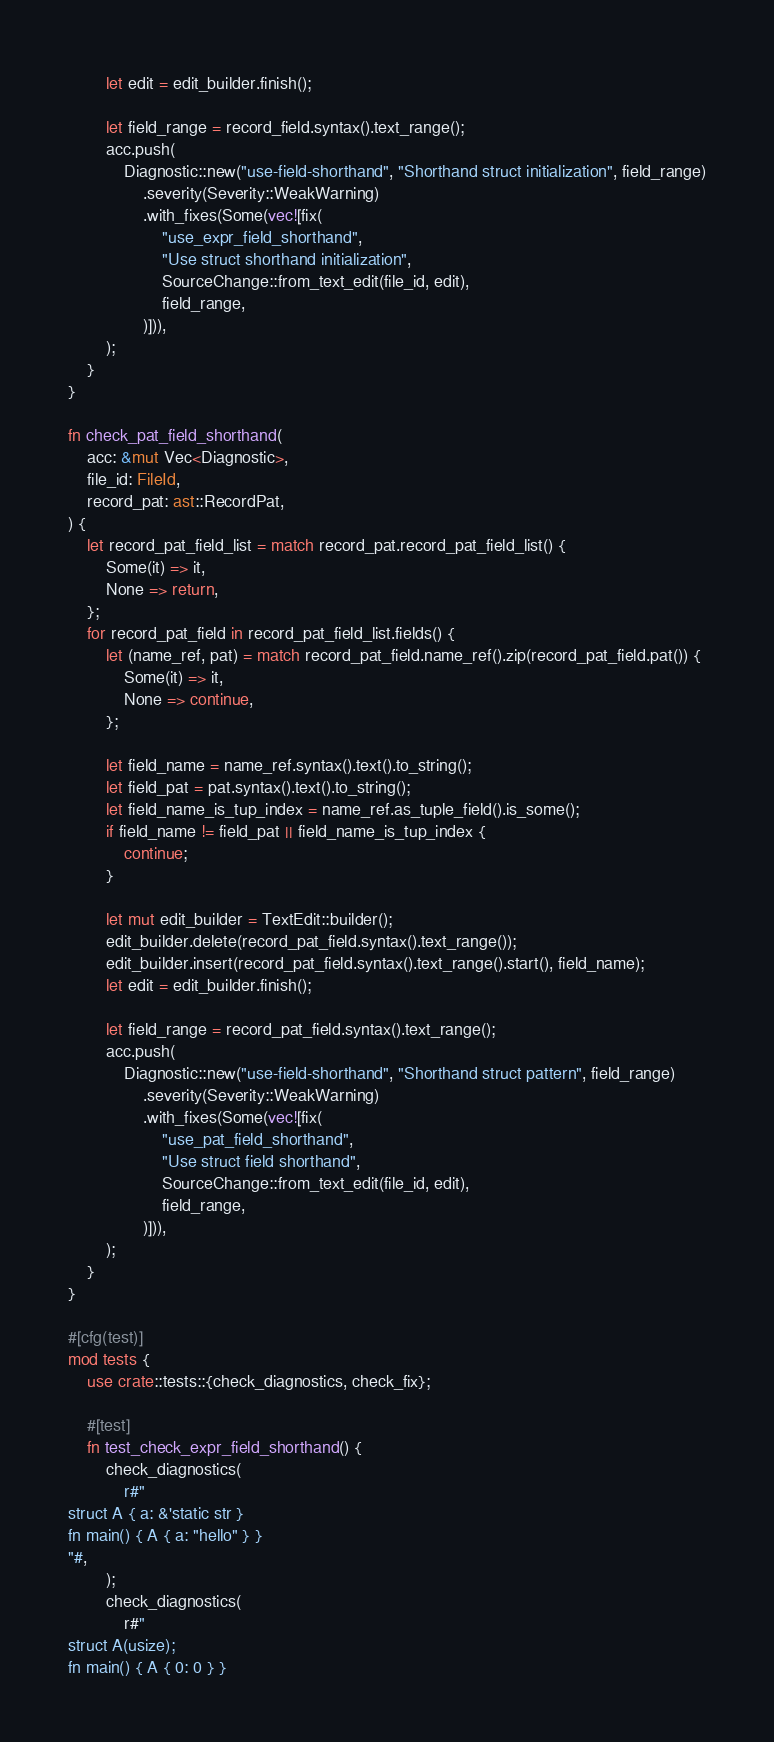Convert code to text. <code><loc_0><loc_0><loc_500><loc_500><_Rust_>        let edit = edit_builder.finish();

        let field_range = record_field.syntax().text_range();
        acc.push(
            Diagnostic::new("use-field-shorthand", "Shorthand struct initialization", field_range)
                .severity(Severity::WeakWarning)
                .with_fixes(Some(vec![fix(
                    "use_expr_field_shorthand",
                    "Use struct shorthand initialization",
                    SourceChange::from_text_edit(file_id, edit),
                    field_range,
                )])),
        );
    }
}

fn check_pat_field_shorthand(
    acc: &mut Vec<Diagnostic>,
    file_id: FileId,
    record_pat: ast::RecordPat,
) {
    let record_pat_field_list = match record_pat.record_pat_field_list() {
        Some(it) => it,
        None => return,
    };
    for record_pat_field in record_pat_field_list.fields() {
        let (name_ref, pat) = match record_pat_field.name_ref().zip(record_pat_field.pat()) {
            Some(it) => it,
            None => continue,
        };

        let field_name = name_ref.syntax().text().to_string();
        let field_pat = pat.syntax().text().to_string();
        let field_name_is_tup_index = name_ref.as_tuple_field().is_some();
        if field_name != field_pat || field_name_is_tup_index {
            continue;
        }

        let mut edit_builder = TextEdit::builder();
        edit_builder.delete(record_pat_field.syntax().text_range());
        edit_builder.insert(record_pat_field.syntax().text_range().start(), field_name);
        let edit = edit_builder.finish();

        let field_range = record_pat_field.syntax().text_range();
        acc.push(
            Diagnostic::new("use-field-shorthand", "Shorthand struct pattern", field_range)
                .severity(Severity::WeakWarning)
                .with_fixes(Some(vec![fix(
                    "use_pat_field_shorthand",
                    "Use struct field shorthand",
                    SourceChange::from_text_edit(file_id, edit),
                    field_range,
                )])),
        );
    }
}

#[cfg(test)]
mod tests {
    use crate::tests::{check_diagnostics, check_fix};

    #[test]
    fn test_check_expr_field_shorthand() {
        check_diagnostics(
            r#"
struct A { a: &'static str }
fn main() { A { a: "hello" } }
"#,
        );
        check_diagnostics(
            r#"
struct A(usize);
fn main() { A { 0: 0 } }</code> 